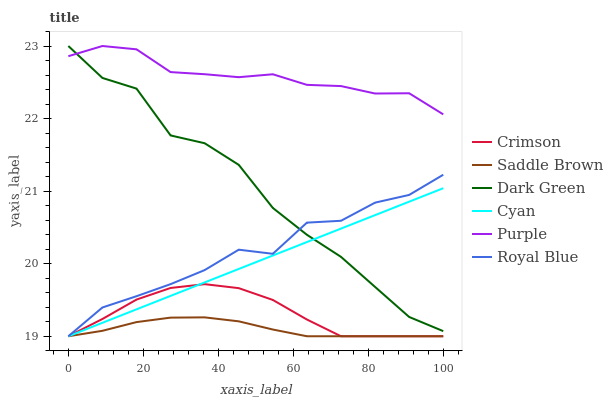Does Saddle Brown have the minimum area under the curve?
Answer yes or no. Yes. Does Purple have the maximum area under the curve?
Answer yes or no. Yes. Does Royal Blue have the minimum area under the curve?
Answer yes or no. No. Does Royal Blue have the maximum area under the curve?
Answer yes or no. No. Is Cyan the smoothest?
Answer yes or no. Yes. Is Dark Green the roughest?
Answer yes or no. Yes. Is Royal Blue the smoothest?
Answer yes or no. No. Is Royal Blue the roughest?
Answer yes or no. No. Does Royal Blue have the lowest value?
Answer yes or no. Yes. Does Dark Green have the lowest value?
Answer yes or no. No. Does Dark Green have the highest value?
Answer yes or no. Yes. Does Royal Blue have the highest value?
Answer yes or no. No. Is Royal Blue less than Purple?
Answer yes or no. Yes. Is Purple greater than Cyan?
Answer yes or no. Yes. Does Cyan intersect Crimson?
Answer yes or no. Yes. Is Cyan less than Crimson?
Answer yes or no. No. Is Cyan greater than Crimson?
Answer yes or no. No. Does Royal Blue intersect Purple?
Answer yes or no. No. 